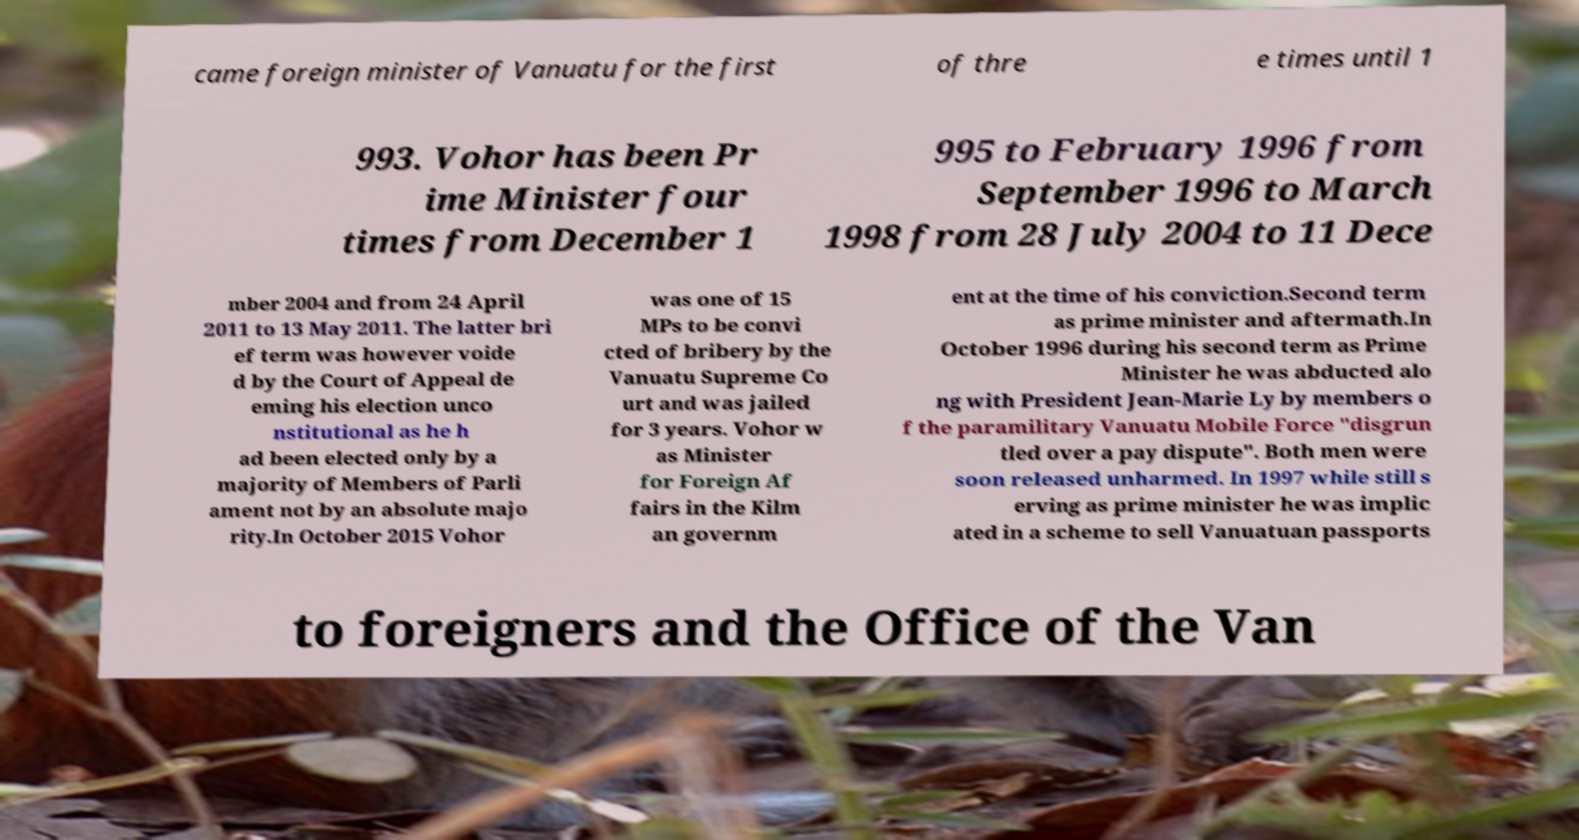Can you read and provide the text displayed in the image?This photo seems to have some interesting text. Can you extract and type it out for me? came foreign minister of Vanuatu for the first of thre e times until 1 993. Vohor has been Pr ime Minister four times from December 1 995 to February 1996 from September 1996 to March 1998 from 28 July 2004 to 11 Dece mber 2004 and from 24 April 2011 to 13 May 2011. The latter bri ef term was however voide d by the Court of Appeal de eming his election unco nstitutional as he h ad been elected only by a majority of Members of Parli ament not by an absolute majo rity.In October 2015 Vohor was one of 15 MPs to be convi cted of bribery by the Vanuatu Supreme Co urt and was jailed for 3 years. Vohor w as Minister for Foreign Af fairs in the Kilm an governm ent at the time of his conviction.Second term as prime minister and aftermath.In October 1996 during his second term as Prime Minister he was abducted alo ng with President Jean-Marie Ly by members o f the paramilitary Vanuatu Mobile Force "disgrun tled over a pay dispute". Both men were soon released unharmed. In 1997 while still s erving as prime minister he was implic ated in a scheme to sell Vanuatuan passports to foreigners and the Office of the Van 